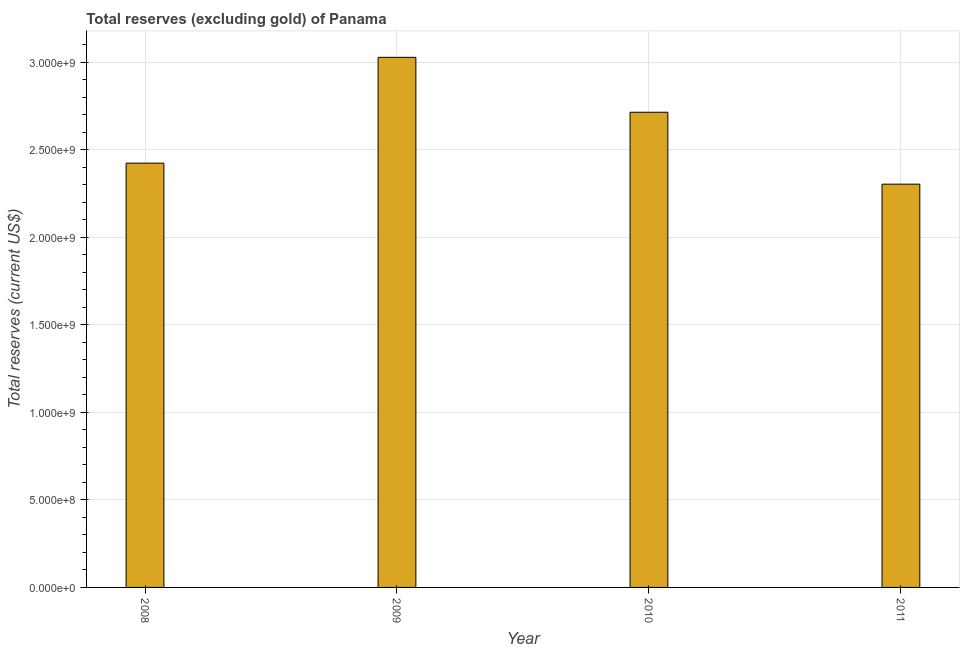Does the graph contain any zero values?
Offer a very short reply. No. Does the graph contain grids?
Your answer should be compact. Yes. What is the title of the graph?
Give a very brief answer. Total reserves (excluding gold) of Panama. What is the label or title of the X-axis?
Your response must be concise. Year. What is the label or title of the Y-axis?
Your answer should be very brief. Total reserves (current US$). What is the total reserves (excluding gold) in 2011?
Keep it short and to the point. 2.30e+09. Across all years, what is the maximum total reserves (excluding gold)?
Your answer should be very brief. 3.03e+09. Across all years, what is the minimum total reserves (excluding gold)?
Provide a short and direct response. 2.30e+09. What is the sum of the total reserves (excluding gold)?
Give a very brief answer. 1.05e+1. What is the difference between the total reserves (excluding gold) in 2010 and 2011?
Provide a short and direct response. 4.11e+08. What is the average total reserves (excluding gold) per year?
Your answer should be compact. 2.62e+09. What is the median total reserves (excluding gold)?
Offer a terse response. 2.57e+09. Do a majority of the years between 2009 and 2010 (inclusive) have total reserves (excluding gold) greater than 2000000000 US$?
Your answer should be very brief. Yes. What is the ratio of the total reserves (excluding gold) in 2010 to that in 2011?
Offer a terse response. 1.18. Is the total reserves (excluding gold) in 2008 less than that in 2009?
Provide a succinct answer. Yes. What is the difference between the highest and the second highest total reserves (excluding gold)?
Offer a terse response. 3.14e+08. Is the sum of the total reserves (excluding gold) in 2009 and 2011 greater than the maximum total reserves (excluding gold) across all years?
Provide a short and direct response. Yes. What is the difference between the highest and the lowest total reserves (excluding gold)?
Keep it short and to the point. 7.25e+08. Are all the bars in the graph horizontal?
Keep it short and to the point. No. What is the Total reserves (current US$) of 2008?
Provide a short and direct response. 2.42e+09. What is the Total reserves (current US$) in 2009?
Offer a terse response. 3.03e+09. What is the Total reserves (current US$) of 2010?
Provide a short and direct response. 2.71e+09. What is the Total reserves (current US$) of 2011?
Offer a terse response. 2.30e+09. What is the difference between the Total reserves (current US$) in 2008 and 2009?
Provide a short and direct response. -6.04e+08. What is the difference between the Total reserves (current US$) in 2008 and 2010?
Your answer should be very brief. -2.91e+08. What is the difference between the Total reserves (current US$) in 2008 and 2011?
Your answer should be compact. 1.20e+08. What is the difference between the Total reserves (current US$) in 2009 and 2010?
Your answer should be very brief. 3.14e+08. What is the difference between the Total reserves (current US$) in 2009 and 2011?
Your answer should be very brief. 7.25e+08. What is the difference between the Total reserves (current US$) in 2010 and 2011?
Give a very brief answer. 4.11e+08. What is the ratio of the Total reserves (current US$) in 2008 to that in 2009?
Make the answer very short. 0.8. What is the ratio of the Total reserves (current US$) in 2008 to that in 2010?
Your answer should be compact. 0.89. What is the ratio of the Total reserves (current US$) in 2008 to that in 2011?
Offer a very short reply. 1.05. What is the ratio of the Total reserves (current US$) in 2009 to that in 2010?
Your answer should be compact. 1.12. What is the ratio of the Total reserves (current US$) in 2009 to that in 2011?
Your answer should be very brief. 1.31. What is the ratio of the Total reserves (current US$) in 2010 to that in 2011?
Provide a short and direct response. 1.18. 